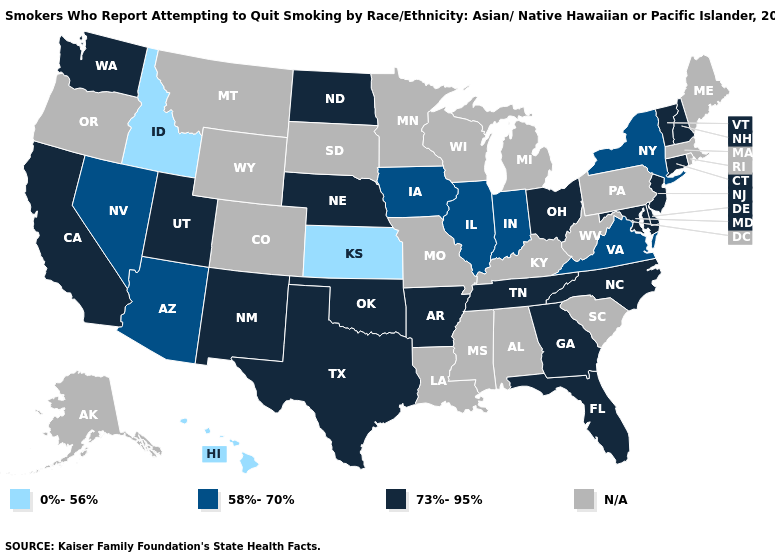What is the value of South Dakota?
Be succinct. N/A. Name the states that have a value in the range 0%-56%?
Keep it brief. Hawaii, Idaho, Kansas. Which states hav the highest value in the South?
Answer briefly. Arkansas, Delaware, Florida, Georgia, Maryland, North Carolina, Oklahoma, Tennessee, Texas. Name the states that have a value in the range N/A?
Short answer required. Alabama, Alaska, Colorado, Kentucky, Louisiana, Maine, Massachusetts, Michigan, Minnesota, Mississippi, Missouri, Montana, Oregon, Pennsylvania, Rhode Island, South Carolina, South Dakota, West Virginia, Wisconsin, Wyoming. Which states have the lowest value in the West?
Concise answer only. Hawaii, Idaho. Name the states that have a value in the range 73%-95%?
Give a very brief answer. Arkansas, California, Connecticut, Delaware, Florida, Georgia, Maryland, Nebraska, New Hampshire, New Jersey, New Mexico, North Carolina, North Dakota, Ohio, Oklahoma, Tennessee, Texas, Utah, Vermont, Washington. Name the states that have a value in the range 58%-70%?
Quick response, please. Arizona, Illinois, Indiana, Iowa, Nevada, New York, Virginia. How many symbols are there in the legend?
Short answer required. 4. What is the lowest value in the West?
Answer briefly. 0%-56%. What is the value of Rhode Island?
Concise answer only. N/A. What is the value of Montana?
Write a very short answer. N/A. Does Hawaii have the lowest value in the USA?
Write a very short answer. Yes. Among the states that border New Mexico , does Utah have the lowest value?
Quick response, please. No. 